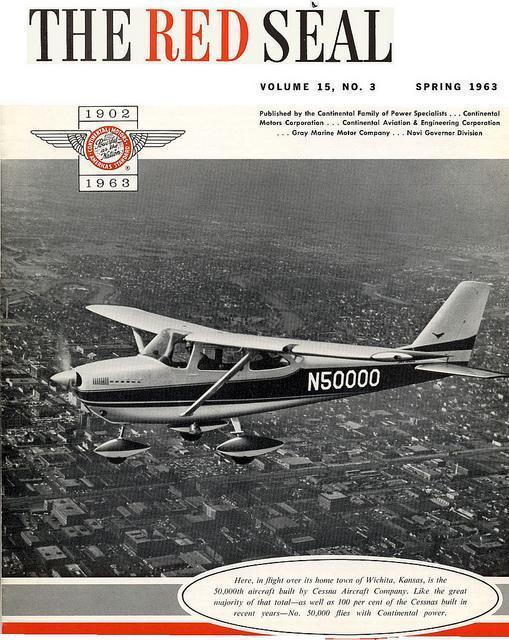How many horses in the picture?
Give a very brief answer. 0. 